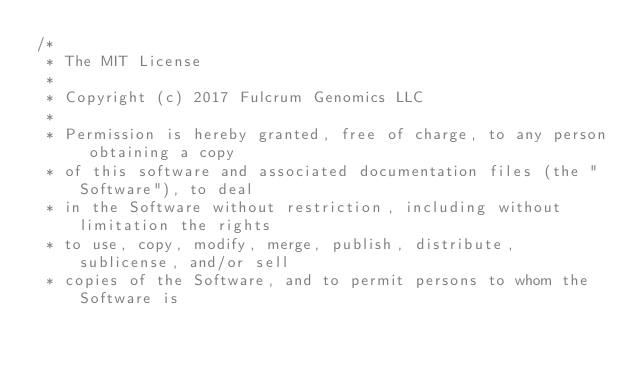<code> <loc_0><loc_0><loc_500><loc_500><_Scala_>/*
 * The MIT License
 *
 * Copyright (c) 2017 Fulcrum Genomics LLC
 *
 * Permission is hereby granted, free of charge, to any person obtaining a copy
 * of this software and associated documentation files (the "Software"), to deal
 * in the Software without restriction, including without limitation the rights
 * to use, copy, modify, merge, publish, distribute, sublicense, and/or sell
 * copies of the Software, and to permit persons to whom the Software is</code> 